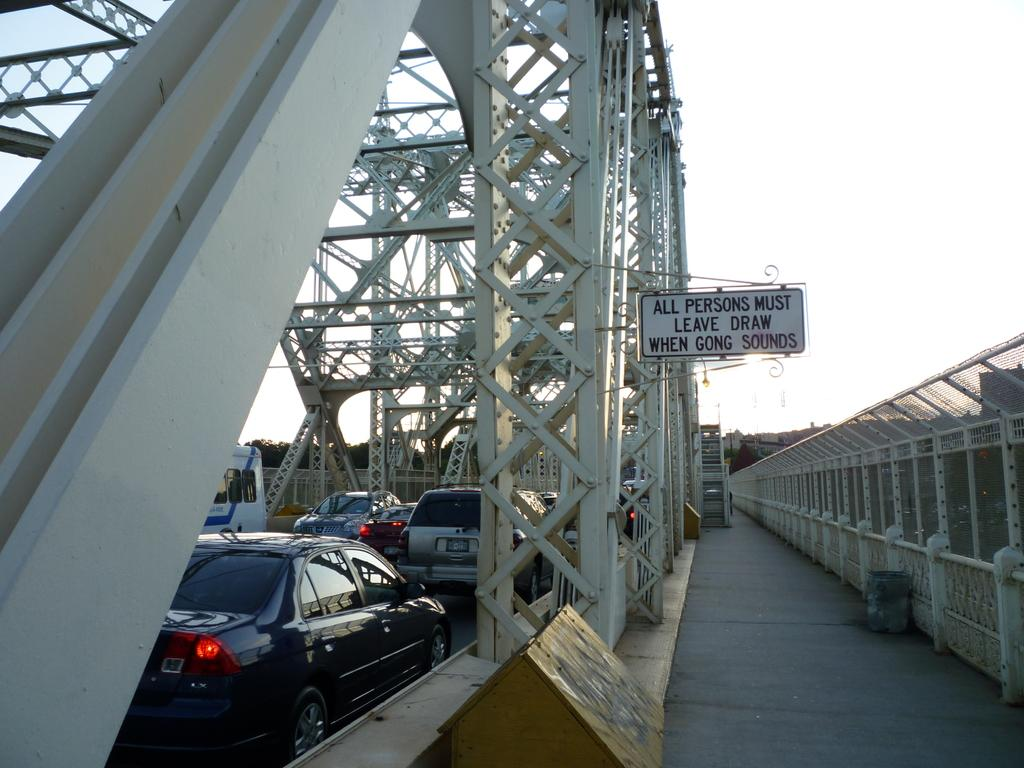What is the main feature of the image? There is a road in the image. What objects can be seen alongside the road? Iron poles are present in the image. What else is visible on the road? There are vehicles present in the image. What message or information is displayed in the image? There is a board with text in the image. What is the weather like in the image? The sky is clear in the image. Can you see a volcano erupting in the image? No, there is no volcano present in the image. What type of neck accessory is being worn by the iron poles in the image? The iron poles are inanimate objects and do not wear any accessories, including neck accessories. 